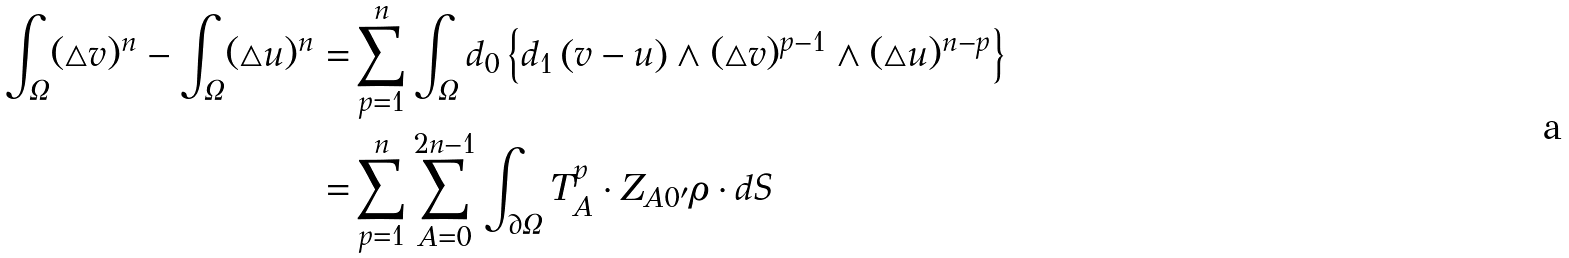Convert formula to latex. <formula><loc_0><loc_0><loc_500><loc_500>\int _ { \Omega } ( \triangle v ) ^ { n } - \int _ { \Omega } ( \triangle u ) ^ { n } = & \sum _ { p = 1 } ^ { n } \int _ { \Omega } d _ { 0 } \left \{ d _ { 1 } \left ( v - u \right ) \wedge ( \triangle v ) ^ { p - 1 } \wedge ( \triangle u ) ^ { n - p } \right \} \\ = & \sum _ { p = 1 } ^ { n } \sum _ { A = 0 } ^ { 2 n - 1 } \int _ { \partial \Omega } T _ { A } ^ { p } \cdot Z _ { A 0 ^ { \prime } } \rho \cdot d S</formula> 